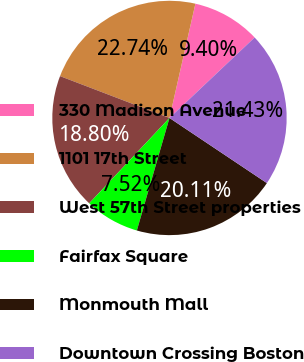Convert chart. <chart><loc_0><loc_0><loc_500><loc_500><pie_chart><fcel>330 Madison Avenue<fcel>1101 17th Street<fcel>West 57th Street properties<fcel>Fairfax Square<fcel>Monmouth Mall<fcel>Downtown Crossing Boston<nl><fcel>9.4%<fcel>22.74%<fcel>18.8%<fcel>7.52%<fcel>20.11%<fcel>21.43%<nl></chart> 